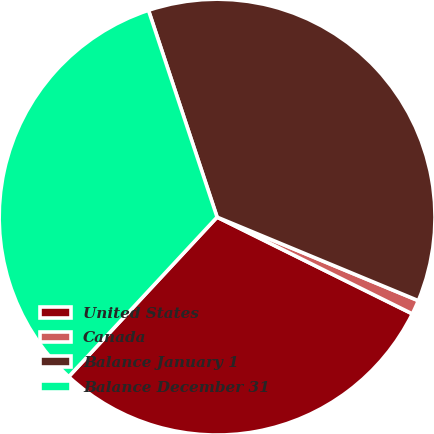Convert chart to OTSL. <chart><loc_0><loc_0><loc_500><loc_500><pie_chart><fcel>United States<fcel>Canada<fcel>Balance January 1<fcel>Balance December 31<nl><fcel>29.6%<fcel>1.06%<fcel>36.36%<fcel>32.98%<nl></chart> 